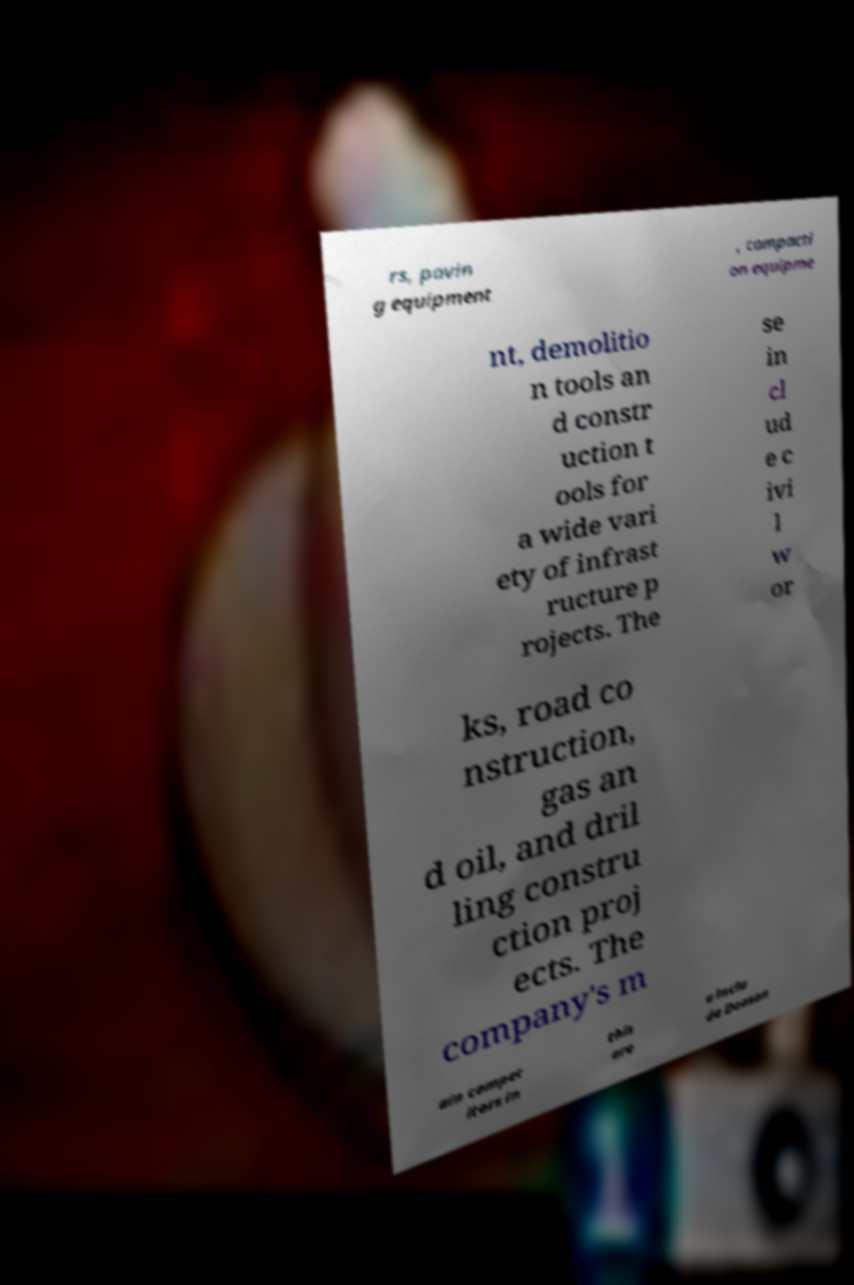Can you read and provide the text displayed in the image?This photo seems to have some interesting text. Can you extract and type it out for me? rs, pavin g equipment , compacti on equipme nt, demolitio n tools an d constr uction t ools for a wide vari ety of infrast ructure p rojects. The se in cl ud e c ivi l w or ks, road co nstruction, gas an d oil, and dril ling constru ction proj ects. The company's m ain compet itors in this are a inclu de Doosan 